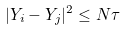<formula> <loc_0><loc_0><loc_500><loc_500>| Y _ { i } - Y _ { j } | ^ { 2 } \leq N \tau</formula> 